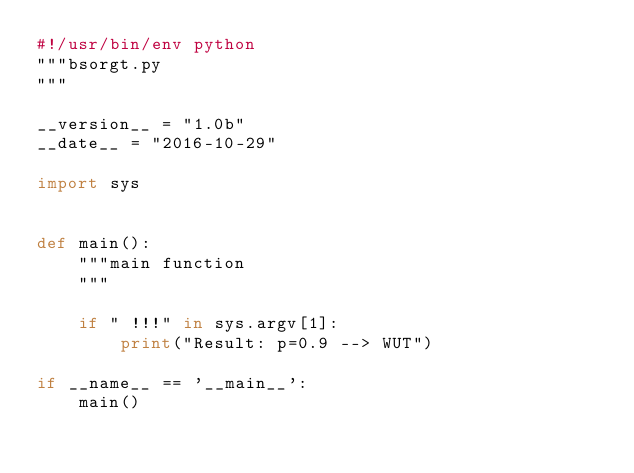Convert code to text. <code><loc_0><loc_0><loc_500><loc_500><_Python_>#!/usr/bin/env python
"""bsorgt.py
"""

__version__ = "1.0b"
__date__ = "2016-10-29"

import sys


def main():
    """main function
    """

    if " !!!" in sys.argv[1]:
        print("Result: p=0.9 --> WUT")

if __name__ == '__main__':
    main()
</code> 